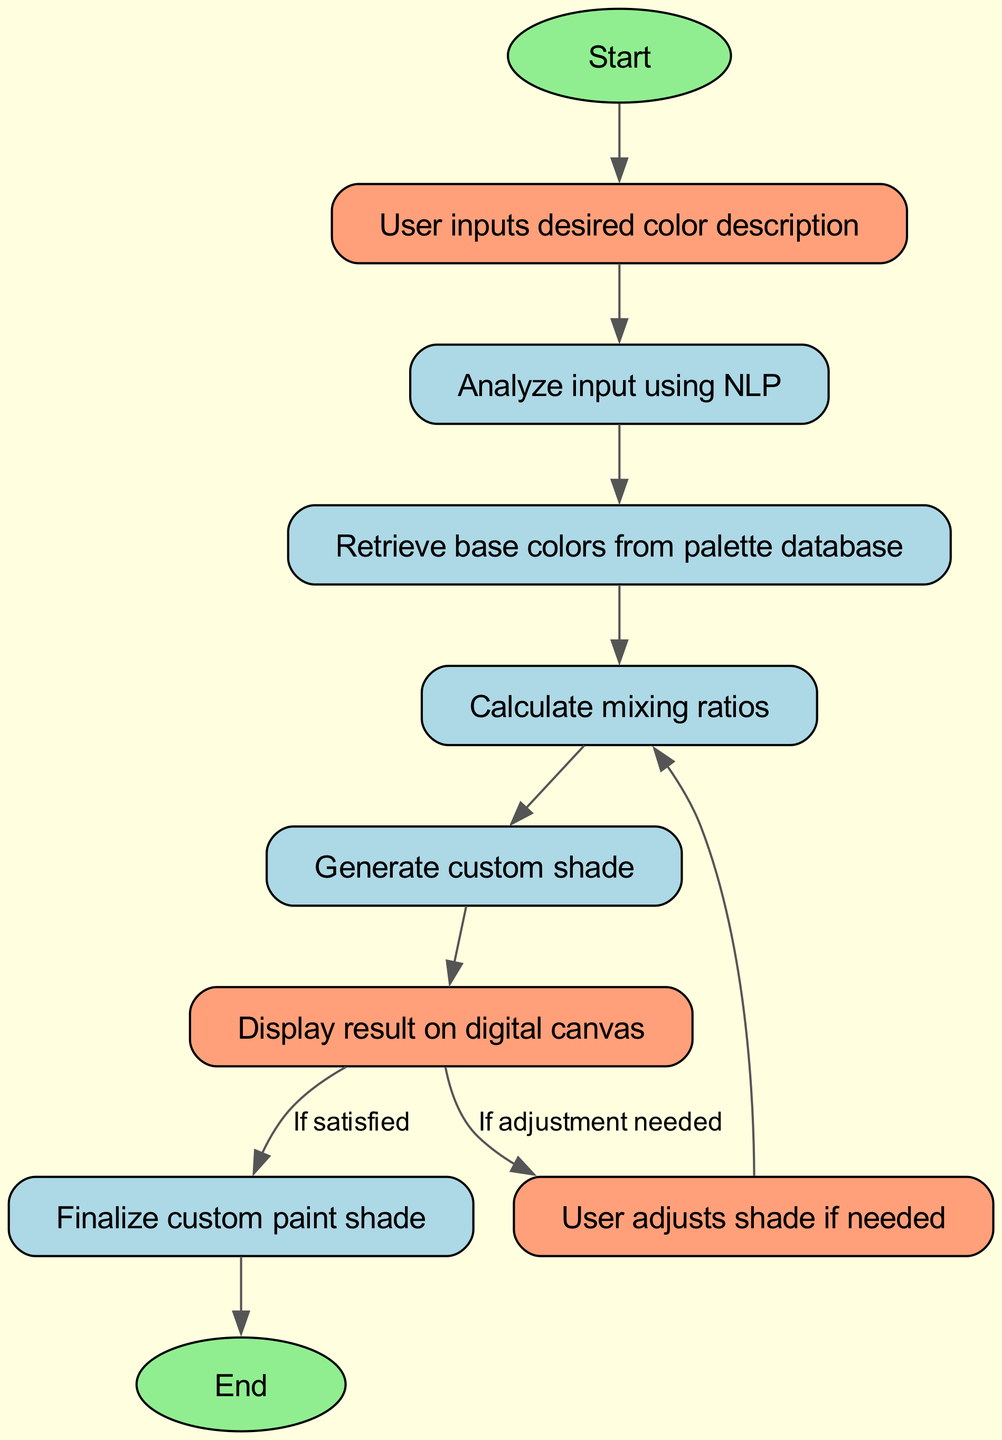What is the first node in the diagram? The first node in the diagram is the "Start" node, as indicated in the flowchart layout.
Answer: Start How many user interaction nodes are present? There are three user interaction nodes: "input," "display," and "adjust." This is counted from the nodes that involve user actions.
Answer: 3 What is the last node in the flowchart? The last node in the flowchart is "End," which signifies the conclusion of the process.
Answer: End Which node follows the "retrieve" node? The "calculate" node follows the "retrieve" node according to the flow of the diagram, showing the next action in the process.
Answer: calculate What happens if the user is satisfied with the result? If the user is satisfied, the process flows to the "finalize" node, indicating completion of the custom shade creation.
Answer: finalize How many edges are there that lead to the "display" node? There is only one edge that leads to the "display" node, which comes directly from the "generate" node.
Answer: 1 What action is taken when the user decides to adjust the shade? When the user decides to adjust the shade, it goes back to the "calculate" node, allowing for new mixing ratios to be determined.
Answer: calculate What is the purpose of the "analyze" node? The purpose of the "analyze" node is to utilize natural language processing (NLP) to understand the user's input.
Answer: Analyze input using NLP Which node requires user input to proceed? The "input" node requires user input before any other operations can take place, initiating the color mixing process.
Answer: User inputs desired color description 